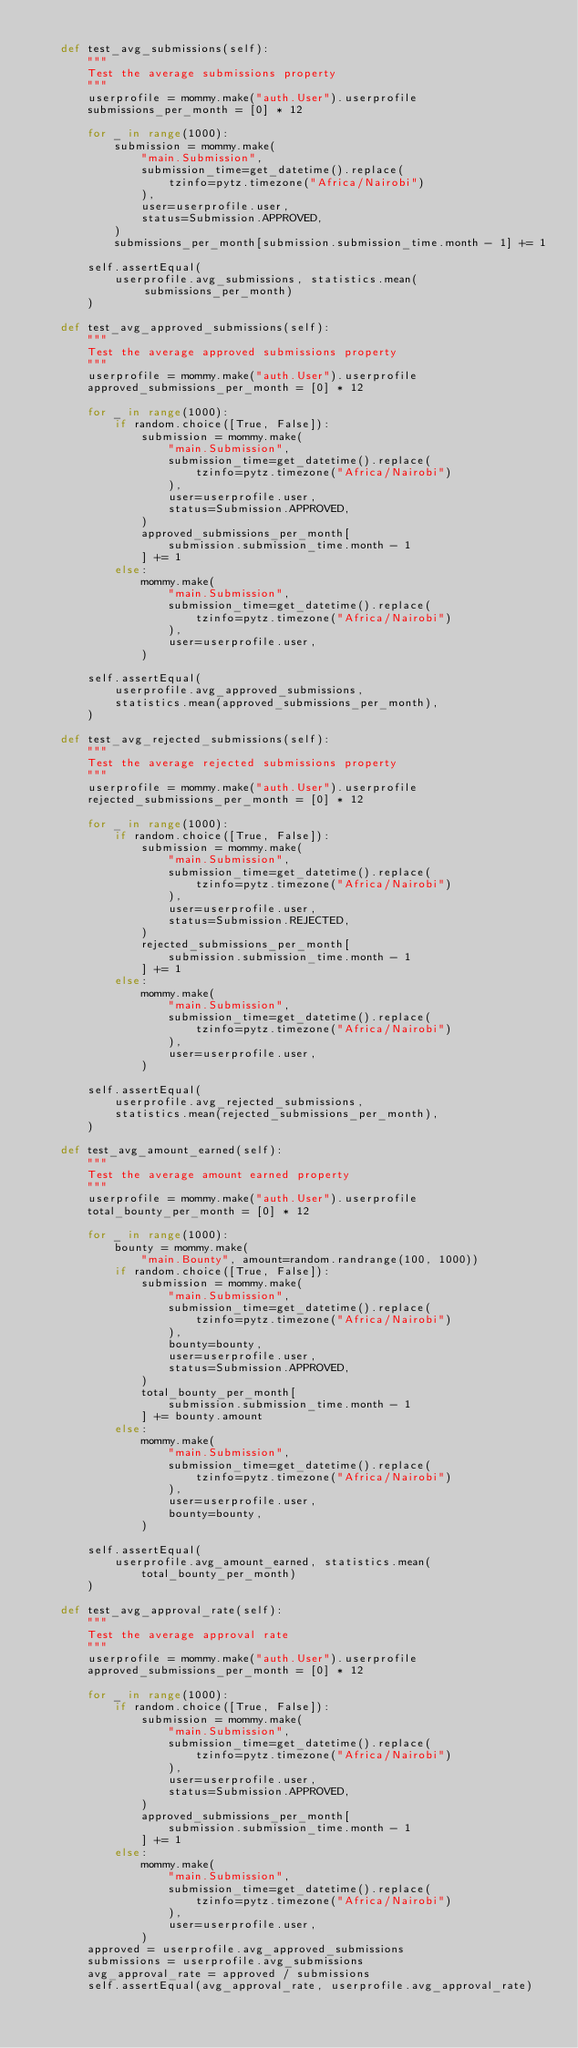Convert code to text. <code><loc_0><loc_0><loc_500><loc_500><_Python_>
    def test_avg_submissions(self):
        """
        Test the average submissions property
        """
        userprofile = mommy.make("auth.User").userprofile
        submissions_per_month = [0] * 12

        for _ in range(1000):
            submission = mommy.make(
                "main.Submission",
                submission_time=get_datetime().replace(
                    tzinfo=pytz.timezone("Africa/Nairobi")
                ),
                user=userprofile.user,
                status=Submission.APPROVED,
            )
            submissions_per_month[submission.submission_time.month - 1] += 1

        self.assertEqual(
            userprofile.avg_submissions, statistics.mean(submissions_per_month)
        )

    def test_avg_approved_submissions(self):
        """
        Test the average approved submissions property
        """
        userprofile = mommy.make("auth.User").userprofile
        approved_submissions_per_month = [0] * 12

        for _ in range(1000):
            if random.choice([True, False]):
                submission = mommy.make(
                    "main.Submission",
                    submission_time=get_datetime().replace(
                        tzinfo=pytz.timezone("Africa/Nairobi")
                    ),
                    user=userprofile.user,
                    status=Submission.APPROVED,
                )
                approved_submissions_per_month[
                    submission.submission_time.month - 1
                ] += 1
            else:
                mommy.make(
                    "main.Submission",
                    submission_time=get_datetime().replace(
                        tzinfo=pytz.timezone("Africa/Nairobi")
                    ),
                    user=userprofile.user,
                )

        self.assertEqual(
            userprofile.avg_approved_submissions,
            statistics.mean(approved_submissions_per_month),
        )

    def test_avg_rejected_submissions(self):
        """
        Test the average rejected submissions property
        """
        userprofile = mommy.make("auth.User").userprofile
        rejected_submissions_per_month = [0] * 12

        for _ in range(1000):
            if random.choice([True, False]):
                submission = mommy.make(
                    "main.Submission",
                    submission_time=get_datetime().replace(
                        tzinfo=pytz.timezone("Africa/Nairobi")
                    ),
                    user=userprofile.user,
                    status=Submission.REJECTED,
                )
                rejected_submissions_per_month[
                    submission.submission_time.month - 1
                ] += 1
            else:
                mommy.make(
                    "main.Submission",
                    submission_time=get_datetime().replace(
                        tzinfo=pytz.timezone("Africa/Nairobi")
                    ),
                    user=userprofile.user,
                )

        self.assertEqual(
            userprofile.avg_rejected_submissions,
            statistics.mean(rejected_submissions_per_month),
        )

    def test_avg_amount_earned(self):
        """
        Test the average amount earned property
        """
        userprofile = mommy.make("auth.User").userprofile
        total_bounty_per_month = [0] * 12

        for _ in range(1000):
            bounty = mommy.make(
                "main.Bounty", amount=random.randrange(100, 1000))
            if random.choice([True, False]):
                submission = mommy.make(
                    "main.Submission",
                    submission_time=get_datetime().replace(
                        tzinfo=pytz.timezone("Africa/Nairobi")
                    ),
                    bounty=bounty,
                    user=userprofile.user,
                    status=Submission.APPROVED,
                )
                total_bounty_per_month[
                    submission.submission_time.month - 1
                ] += bounty.amount
            else:
                mommy.make(
                    "main.Submission",
                    submission_time=get_datetime().replace(
                        tzinfo=pytz.timezone("Africa/Nairobi")
                    ),
                    user=userprofile.user,
                    bounty=bounty,
                )

        self.assertEqual(
            userprofile.avg_amount_earned, statistics.mean(
                total_bounty_per_month)
        )

    def test_avg_approval_rate(self):
        """
        Test the average approval rate
        """
        userprofile = mommy.make("auth.User").userprofile
        approved_submissions_per_month = [0] * 12

        for _ in range(1000):
            if random.choice([True, False]):
                submission = mommy.make(
                    "main.Submission",
                    submission_time=get_datetime().replace(
                        tzinfo=pytz.timezone("Africa/Nairobi")
                    ),
                    user=userprofile.user,
                    status=Submission.APPROVED,
                )
                approved_submissions_per_month[
                    submission.submission_time.month - 1
                ] += 1
            else:
                mommy.make(
                    "main.Submission",
                    submission_time=get_datetime().replace(
                        tzinfo=pytz.timezone("Africa/Nairobi")
                    ),
                    user=userprofile.user,
                )
        approved = userprofile.avg_approved_submissions
        submissions = userprofile.avg_submissions
        avg_approval_rate = approved / submissions
        self.assertEqual(avg_approval_rate, userprofile.avg_approval_rate)
</code> 